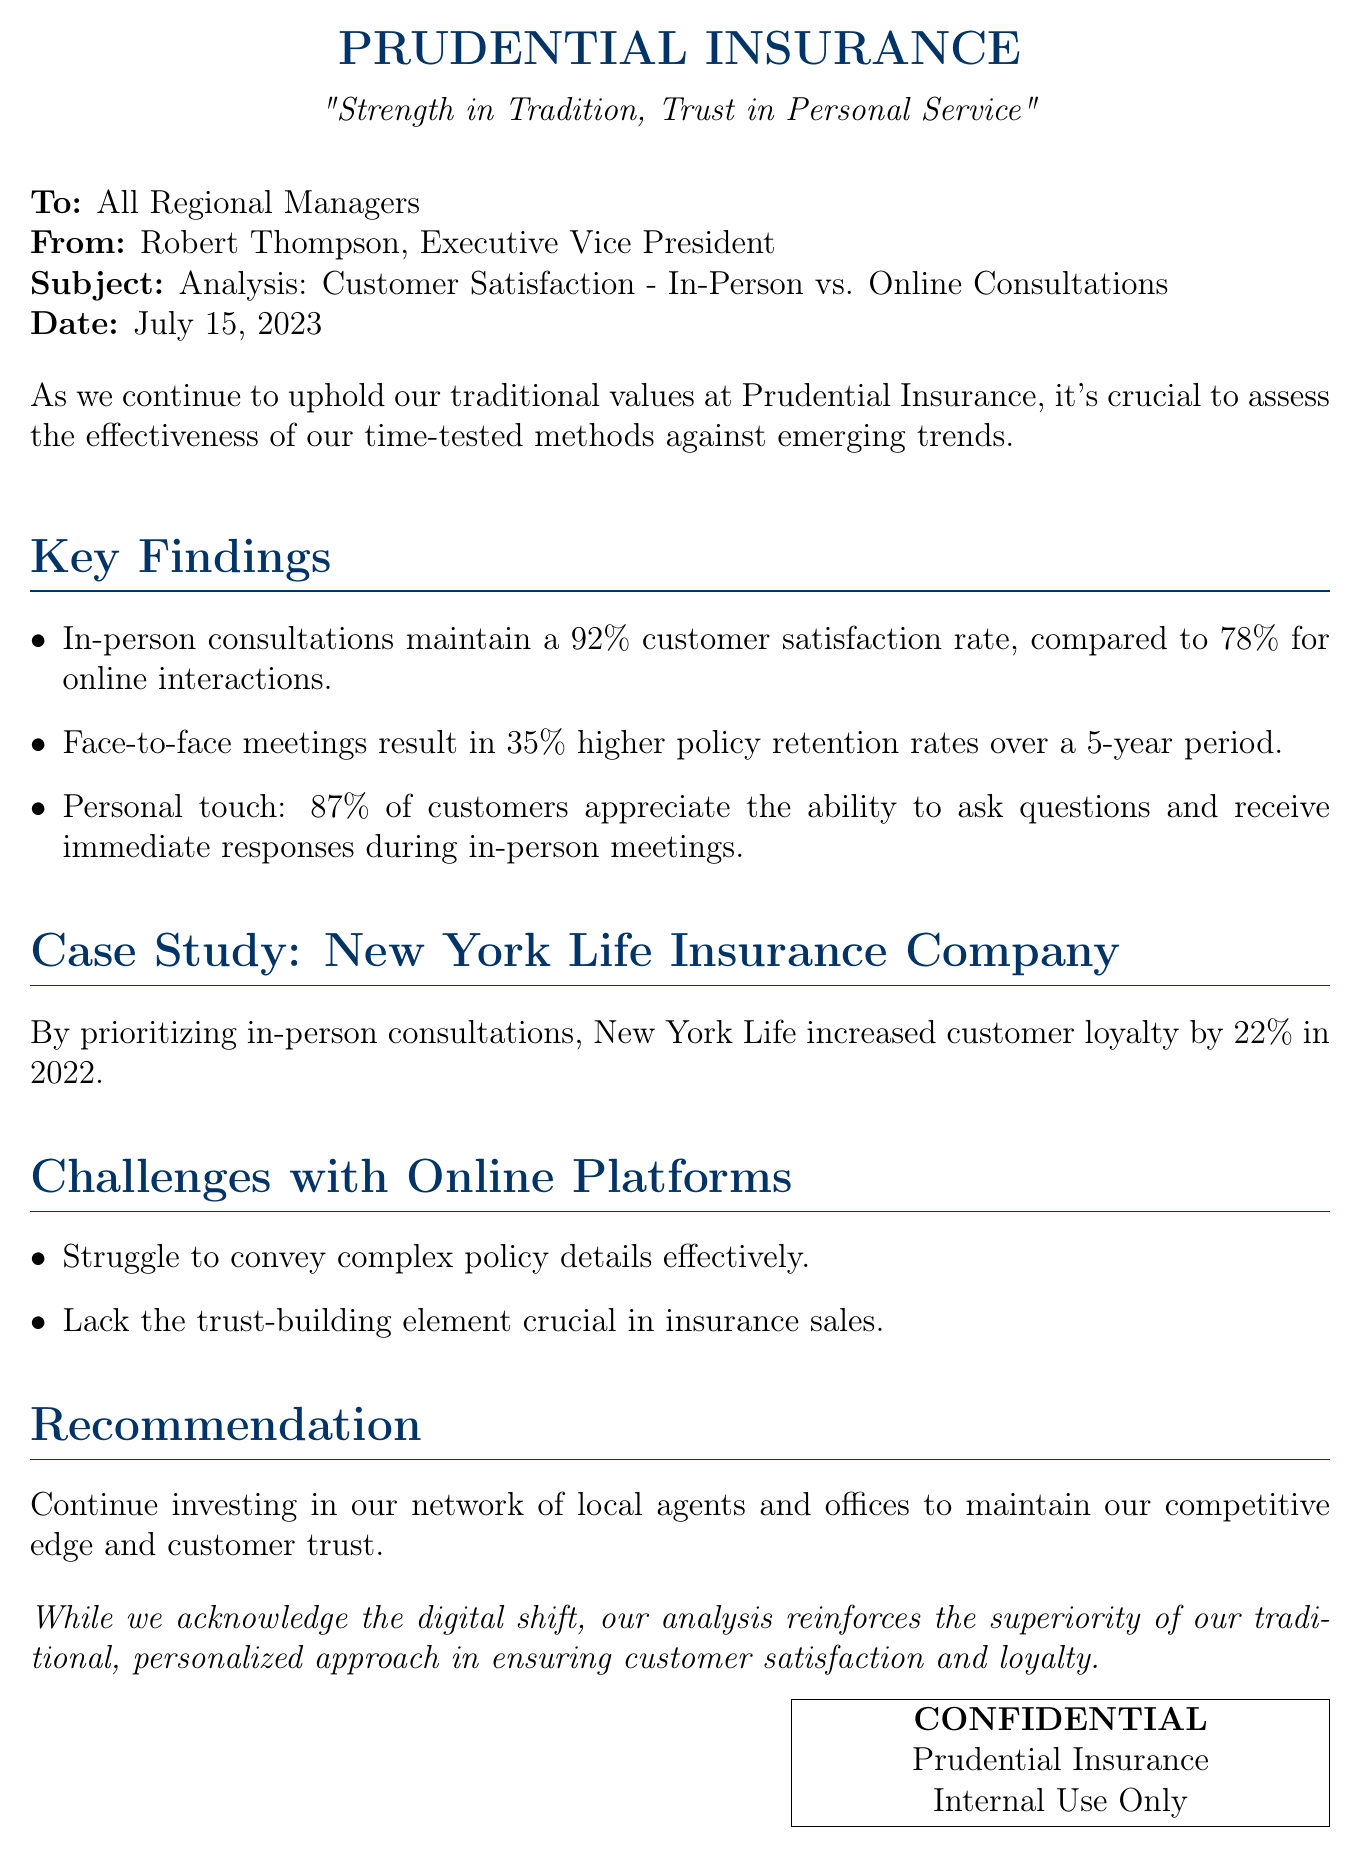What is the customer satisfaction rate for in-person consultations? The document states that in-person consultations maintain a 92% customer satisfaction rate.
Answer: 92% What is the customer satisfaction rate for online interactions? It is mentioned in the document that online interactions have a 78% customer satisfaction rate.
Answer: 78% What percentage of customers appreciate the ability to ask questions during in-person meetings? The document indicates that 87% of customers appreciate this aspect during in-person meetings.
Answer: 87% What year did New York Life Insurance Company increase customer loyalty by 22%? The document specifies that this increase occurred in 2022.
Answer: 2022 How much higher are policy retention rates for in-person meetings over a 5-year period? The document mentions that in-person meetings result in 35% higher policy retention rates.
Answer: 35% What is the recommendation provided in the document? The recommendation is to continue investing in the network of local agents and offices.
Answer: Continue investing in local agents and offices What are the two challenges mentioned with online platforms? The document lists the struggle to convey complex policy details and lack of trust-building as challenges.
Answer: Conveying complex policy details, lack of trust-building Who is the sender of this fax? The document identifies Robert Thompson as the sender.
Answer: Robert Thompson 